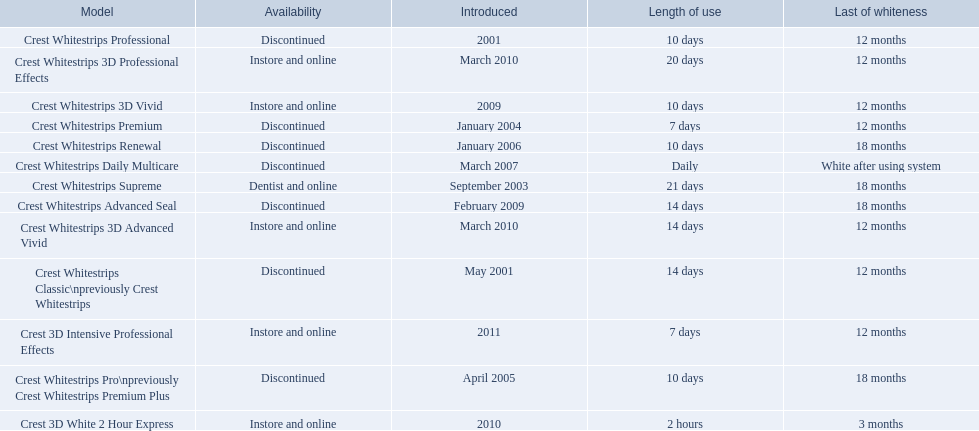What products are listed? Crest Whitestrips Classic\npreviously Crest Whitestrips, Crest Whitestrips Professional, Crest Whitestrips Supreme, Crest Whitestrips Premium, Crest Whitestrips Pro\npreviously Crest Whitestrips Premium Plus, Crest Whitestrips Renewal, Crest Whitestrips Daily Multicare, Crest Whitestrips Advanced Seal, Crest Whitestrips 3D Vivid, Crest Whitestrips 3D Advanced Vivid, Crest Whitestrips 3D Professional Effects, Crest 3D White 2 Hour Express, Crest 3D Intensive Professional Effects. Of these, which was were introduced in march, 2010? Crest Whitestrips 3D Advanced Vivid, Crest Whitestrips 3D Professional Effects. Of these, which were not 3d advanced vivid? Crest Whitestrips 3D Professional Effects. 